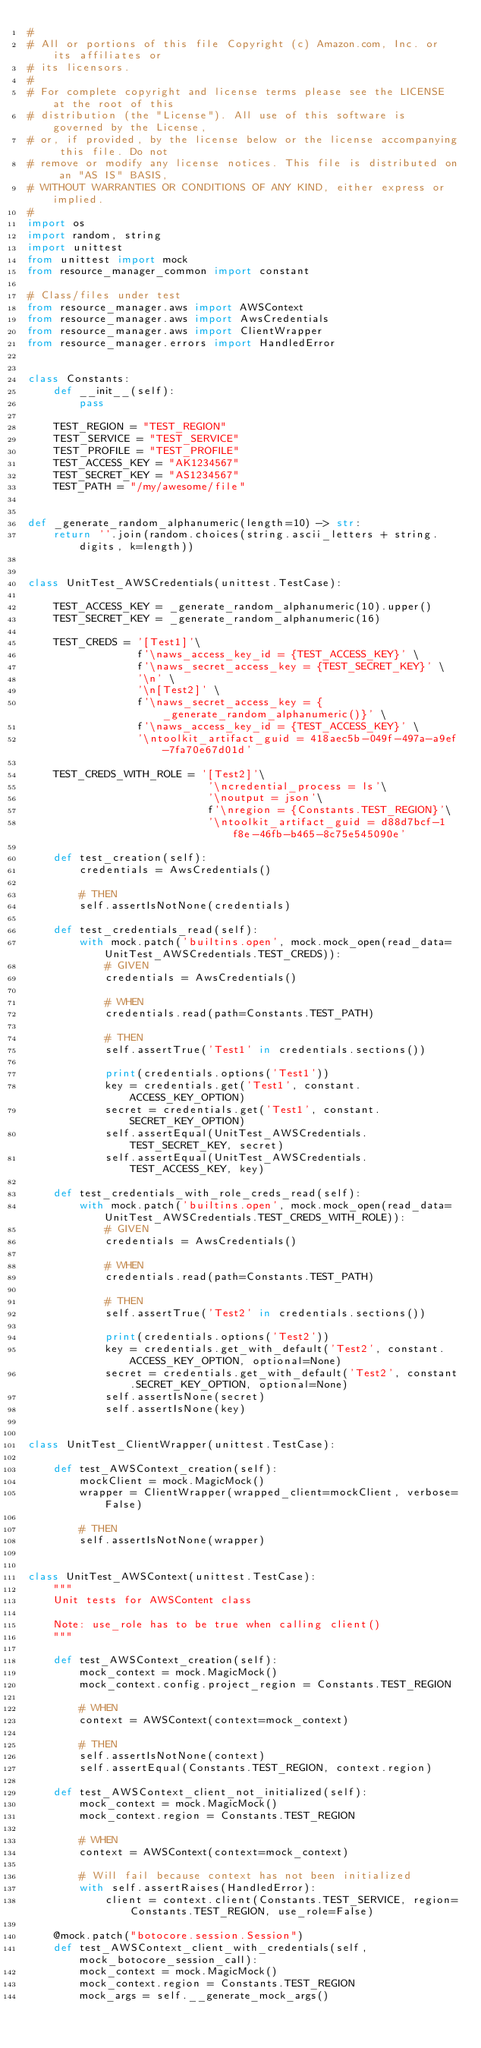Convert code to text. <code><loc_0><loc_0><loc_500><loc_500><_Python_>#
# All or portions of this file Copyright (c) Amazon.com, Inc. or its affiliates or
# its licensors.
#
# For complete copyright and license terms please see the LICENSE at the root of this
# distribution (the "License"). All use of this software is governed by the License,
# or, if provided, by the license below or the license accompanying this file. Do not
# remove or modify any license notices. This file is distributed on an "AS IS" BASIS,
# WITHOUT WARRANTIES OR CONDITIONS OF ANY KIND, either express or implied.
#
import os
import random, string
import unittest
from unittest import mock
from resource_manager_common import constant

# Class/files under test
from resource_manager.aws import AWSContext
from resource_manager.aws import AwsCredentials
from resource_manager.aws import ClientWrapper
from resource_manager.errors import HandledError


class Constants:
    def __init__(self):
        pass

    TEST_REGION = "TEST_REGION"
    TEST_SERVICE = "TEST_SERVICE"
    TEST_PROFILE = "TEST_PROFILE"
    TEST_ACCESS_KEY = "AK1234567"
    TEST_SECRET_KEY = "AS1234567"
    TEST_PATH = "/my/awesome/file"


def _generate_random_alphanumeric(length=10) -> str:
    return ''.join(random.choices(string.ascii_letters + string.digits, k=length))


class UnitTest_AWSCredentials(unittest.TestCase):

    TEST_ACCESS_KEY = _generate_random_alphanumeric(10).upper()
    TEST_SECRET_KEY = _generate_random_alphanumeric(16)

    TEST_CREDS = '[Test1]'\
                 f'\naws_access_key_id = {TEST_ACCESS_KEY}' \
                 f'\naws_secret_access_key = {TEST_SECRET_KEY}' \
                 '\n' \
                 '\n[Test2]' \
                 f'\naws_secret_access_key = {_generate_random_alphanumeric()}' \
                 f'\naws_access_key_id = {TEST_ACCESS_KEY}' \
                 '\ntoolkit_artifact_guid = 418aec5b-049f-497a-a9ef-7fa70e67d01d'

    TEST_CREDS_WITH_ROLE = '[Test2]'\
                            '\ncredential_process = ls'\
                            '\noutput = json'\
                            f'\nregion = {Constants.TEST_REGION}'\
                            '\ntoolkit_artifact_guid = d88d7bcf-1f8e-46fb-b465-8c75e545090e'

    def test_creation(self):
        credentials = AwsCredentials()

        # THEN
        self.assertIsNotNone(credentials)

    def test_credentials_read(self):
        with mock.patch('builtins.open', mock.mock_open(read_data=UnitTest_AWSCredentials.TEST_CREDS)):
            # GIVEN
            credentials = AwsCredentials()

            # WHEN
            credentials.read(path=Constants.TEST_PATH)

            # THEN
            self.assertTrue('Test1' in credentials.sections())

            print(credentials.options('Test1'))
            key = credentials.get('Test1', constant.ACCESS_KEY_OPTION)
            secret = credentials.get('Test1', constant.SECRET_KEY_OPTION)
            self.assertEqual(UnitTest_AWSCredentials.TEST_SECRET_KEY, secret)
            self.assertEqual(UnitTest_AWSCredentials.TEST_ACCESS_KEY, key)

    def test_credentials_with_role_creds_read(self):
        with mock.patch('builtins.open', mock.mock_open(read_data=UnitTest_AWSCredentials.TEST_CREDS_WITH_ROLE)):
            # GIVEN
            credentials = AwsCredentials()

            # WHEN
            credentials.read(path=Constants.TEST_PATH)

            # THEN
            self.assertTrue('Test2' in credentials.sections())

            print(credentials.options('Test2'))
            key = credentials.get_with_default('Test2', constant.ACCESS_KEY_OPTION, optional=None)
            secret = credentials.get_with_default('Test2', constant.SECRET_KEY_OPTION, optional=None)
            self.assertIsNone(secret)
            self.assertIsNone(key)


class UnitTest_ClientWrapper(unittest.TestCase):

    def test_AWSContext_creation(self):
        mockClient = mock.MagicMock()
        wrapper = ClientWrapper(wrapped_client=mockClient, verbose=False)

        # THEN
        self.assertIsNotNone(wrapper)


class UnitTest_AWSContext(unittest.TestCase):
    """
    Unit tests for AWSContent class

    Note: use_role has to be true when calling client()
    """

    def test_AWSContext_creation(self):
        mock_context = mock.MagicMock()
        mock_context.config.project_region = Constants.TEST_REGION

        # WHEN
        context = AWSContext(context=mock_context)

        # THEN
        self.assertIsNotNone(context)
        self.assertEqual(Constants.TEST_REGION, context.region)

    def test_AWSContext_client_not_initialized(self):
        mock_context = mock.MagicMock()
        mock_context.region = Constants.TEST_REGION

        # WHEN
        context = AWSContext(context=mock_context)

        # Will fail because context has not been initialized
        with self.assertRaises(HandledError):
            client = context.client(Constants.TEST_SERVICE, region=Constants.TEST_REGION, use_role=False)

    @mock.patch("botocore.session.Session")
    def test_AWSContext_client_with_credentials(self, mock_botocore_session_call):
        mock_context = mock.MagicMock()
        mock_context.region = Constants.TEST_REGION
        mock_args = self.__generate_mock_args()</code> 